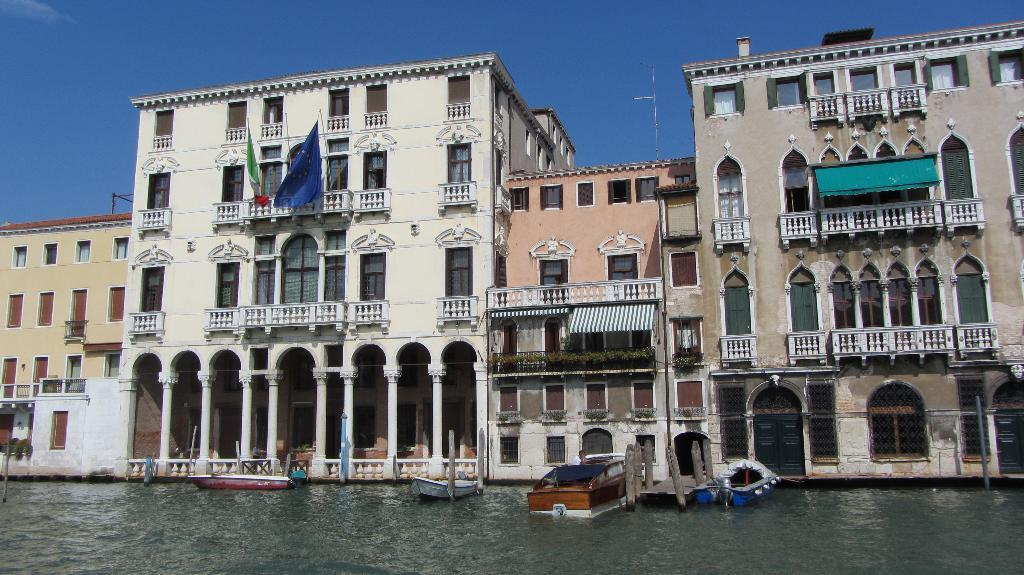What is on the water in the image? There are boats on the water in the image. What type of structures can be seen in the image? There are buildings in the image. What else is present in the image besides the boats and buildings? There are flags with poles in the image. What can be seen in the background of the image? The sky is visible in the background of the image. What type of map can be seen on the boats in the image? There is no map present on the boats in the image. What sound do the bells make in the image? There are no bells present in the image. 